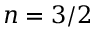<formula> <loc_0><loc_0><loc_500><loc_500>n = 3 / 2</formula> 